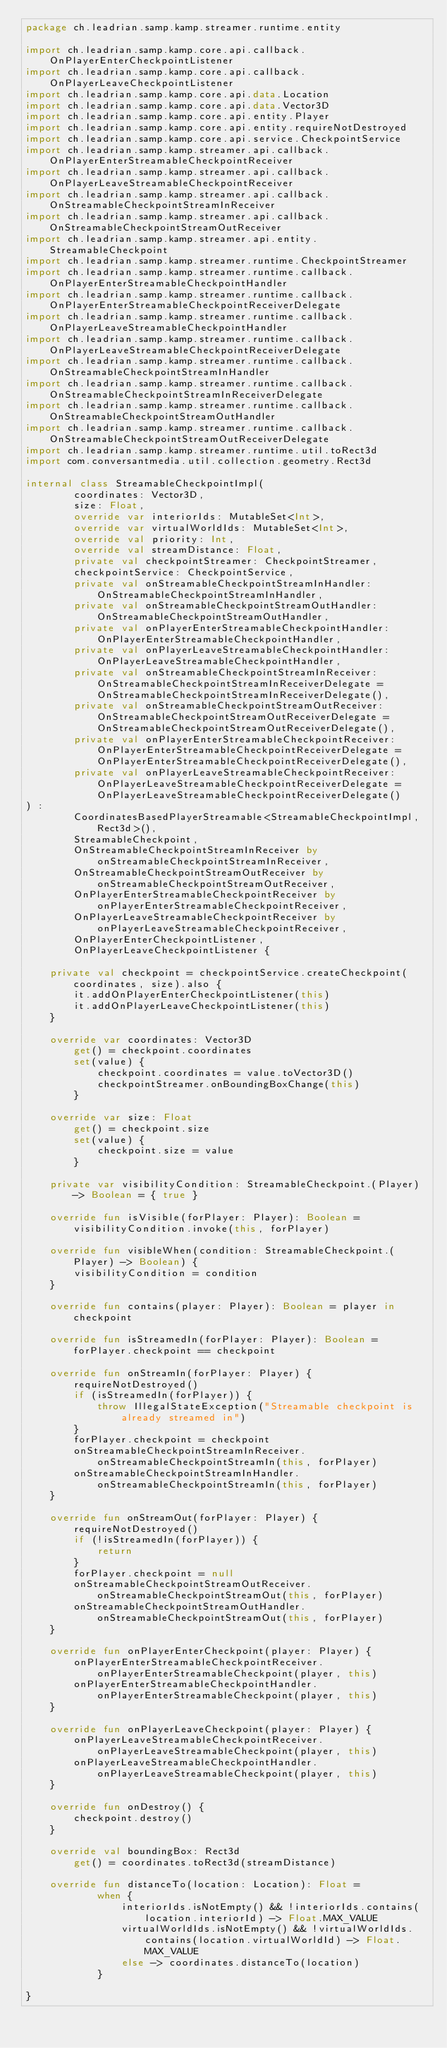<code> <loc_0><loc_0><loc_500><loc_500><_Kotlin_>package ch.leadrian.samp.kamp.streamer.runtime.entity

import ch.leadrian.samp.kamp.core.api.callback.OnPlayerEnterCheckpointListener
import ch.leadrian.samp.kamp.core.api.callback.OnPlayerLeaveCheckpointListener
import ch.leadrian.samp.kamp.core.api.data.Location
import ch.leadrian.samp.kamp.core.api.data.Vector3D
import ch.leadrian.samp.kamp.core.api.entity.Player
import ch.leadrian.samp.kamp.core.api.entity.requireNotDestroyed
import ch.leadrian.samp.kamp.core.api.service.CheckpointService
import ch.leadrian.samp.kamp.streamer.api.callback.OnPlayerEnterStreamableCheckpointReceiver
import ch.leadrian.samp.kamp.streamer.api.callback.OnPlayerLeaveStreamableCheckpointReceiver
import ch.leadrian.samp.kamp.streamer.api.callback.OnStreamableCheckpointStreamInReceiver
import ch.leadrian.samp.kamp.streamer.api.callback.OnStreamableCheckpointStreamOutReceiver
import ch.leadrian.samp.kamp.streamer.api.entity.StreamableCheckpoint
import ch.leadrian.samp.kamp.streamer.runtime.CheckpointStreamer
import ch.leadrian.samp.kamp.streamer.runtime.callback.OnPlayerEnterStreamableCheckpointHandler
import ch.leadrian.samp.kamp.streamer.runtime.callback.OnPlayerEnterStreamableCheckpointReceiverDelegate
import ch.leadrian.samp.kamp.streamer.runtime.callback.OnPlayerLeaveStreamableCheckpointHandler
import ch.leadrian.samp.kamp.streamer.runtime.callback.OnPlayerLeaveStreamableCheckpointReceiverDelegate
import ch.leadrian.samp.kamp.streamer.runtime.callback.OnStreamableCheckpointStreamInHandler
import ch.leadrian.samp.kamp.streamer.runtime.callback.OnStreamableCheckpointStreamInReceiverDelegate
import ch.leadrian.samp.kamp.streamer.runtime.callback.OnStreamableCheckpointStreamOutHandler
import ch.leadrian.samp.kamp.streamer.runtime.callback.OnStreamableCheckpointStreamOutReceiverDelegate
import ch.leadrian.samp.kamp.streamer.runtime.util.toRect3d
import com.conversantmedia.util.collection.geometry.Rect3d

internal class StreamableCheckpointImpl(
        coordinates: Vector3D,
        size: Float,
        override var interiorIds: MutableSet<Int>,
        override var virtualWorldIds: MutableSet<Int>,
        override val priority: Int,
        override val streamDistance: Float,
        private val checkpointStreamer: CheckpointStreamer,
        checkpointService: CheckpointService,
        private val onStreamableCheckpointStreamInHandler: OnStreamableCheckpointStreamInHandler,
        private val onStreamableCheckpointStreamOutHandler: OnStreamableCheckpointStreamOutHandler,
        private val onPlayerEnterStreamableCheckpointHandler: OnPlayerEnterStreamableCheckpointHandler,
        private val onPlayerLeaveStreamableCheckpointHandler: OnPlayerLeaveStreamableCheckpointHandler,
        private val onStreamableCheckpointStreamInReceiver: OnStreamableCheckpointStreamInReceiverDelegate = OnStreamableCheckpointStreamInReceiverDelegate(),
        private val onStreamableCheckpointStreamOutReceiver: OnStreamableCheckpointStreamOutReceiverDelegate = OnStreamableCheckpointStreamOutReceiverDelegate(),
        private val onPlayerEnterStreamableCheckpointReceiver: OnPlayerEnterStreamableCheckpointReceiverDelegate = OnPlayerEnterStreamableCheckpointReceiverDelegate(),
        private val onPlayerLeaveStreamableCheckpointReceiver: OnPlayerLeaveStreamableCheckpointReceiverDelegate = OnPlayerLeaveStreamableCheckpointReceiverDelegate()
) :
        CoordinatesBasedPlayerStreamable<StreamableCheckpointImpl, Rect3d>(),
        StreamableCheckpoint,
        OnStreamableCheckpointStreamInReceiver by onStreamableCheckpointStreamInReceiver,
        OnStreamableCheckpointStreamOutReceiver by onStreamableCheckpointStreamOutReceiver,
        OnPlayerEnterStreamableCheckpointReceiver by onPlayerEnterStreamableCheckpointReceiver,
        OnPlayerLeaveStreamableCheckpointReceiver by onPlayerLeaveStreamableCheckpointReceiver,
        OnPlayerEnterCheckpointListener,
        OnPlayerLeaveCheckpointListener {

    private val checkpoint = checkpointService.createCheckpoint(coordinates, size).also {
        it.addOnPlayerEnterCheckpointListener(this)
        it.addOnPlayerLeaveCheckpointListener(this)
    }

    override var coordinates: Vector3D
        get() = checkpoint.coordinates
        set(value) {
            checkpoint.coordinates = value.toVector3D()
            checkpointStreamer.onBoundingBoxChange(this)
        }

    override var size: Float
        get() = checkpoint.size
        set(value) {
            checkpoint.size = value
        }

    private var visibilityCondition: StreamableCheckpoint.(Player) -> Boolean = { true }

    override fun isVisible(forPlayer: Player): Boolean = visibilityCondition.invoke(this, forPlayer)

    override fun visibleWhen(condition: StreamableCheckpoint.(Player) -> Boolean) {
        visibilityCondition = condition
    }

    override fun contains(player: Player): Boolean = player in checkpoint

    override fun isStreamedIn(forPlayer: Player): Boolean = forPlayer.checkpoint == checkpoint

    override fun onStreamIn(forPlayer: Player) {
        requireNotDestroyed()
        if (isStreamedIn(forPlayer)) {
            throw IllegalStateException("Streamable checkpoint is already streamed in")
        }
        forPlayer.checkpoint = checkpoint
        onStreamableCheckpointStreamInReceiver.onStreamableCheckpointStreamIn(this, forPlayer)
        onStreamableCheckpointStreamInHandler.onStreamableCheckpointStreamIn(this, forPlayer)
    }

    override fun onStreamOut(forPlayer: Player) {
        requireNotDestroyed()
        if (!isStreamedIn(forPlayer)) {
            return
        }
        forPlayer.checkpoint = null
        onStreamableCheckpointStreamOutReceiver.onStreamableCheckpointStreamOut(this, forPlayer)
        onStreamableCheckpointStreamOutHandler.onStreamableCheckpointStreamOut(this, forPlayer)
    }

    override fun onPlayerEnterCheckpoint(player: Player) {
        onPlayerEnterStreamableCheckpointReceiver.onPlayerEnterStreamableCheckpoint(player, this)
        onPlayerEnterStreamableCheckpointHandler.onPlayerEnterStreamableCheckpoint(player, this)
    }

    override fun onPlayerLeaveCheckpoint(player: Player) {
        onPlayerLeaveStreamableCheckpointReceiver.onPlayerLeaveStreamableCheckpoint(player, this)
        onPlayerLeaveStreamableCheckpointHandler.onPlayerLeaveStreamableCheckpoint(player, this)
    }

    override fun onDestroy() {
        checkpoint.destroy()
    }

    override val boundingBox: Rect3d
        get() = coordinates.toRect3d(streamDistance)

    override fun distanceTo(location: Location): Float =
            when {
                interiorIds.isNotEmpty() && !interiorIds.contains(location.interiorId) -> Float.MAX_VALUE
                virtualWorldIds.isNotEmpty() && !virtualWorldIds.contains(location.virtualWorldId) -> Float.MAX_VALUE
                else -> coordinates.distanceTo(location)
            }

}</code> 